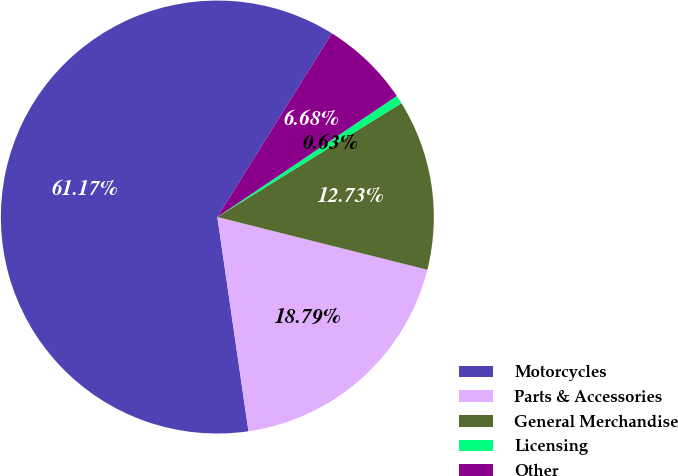Convert chart. <chart><loc_0><loc_0><loc_500><loc_500><pie_chart><fcel>Motorcycles<fcel>Parts & Accessories<fcel>General Merchandise<fcel>Licensing<fcel>Other<nl><fcel>61.17%<fcel>18.79%<fcel>12.73%<fcel>0.63%<fcel>6.68%<nl></chart> 